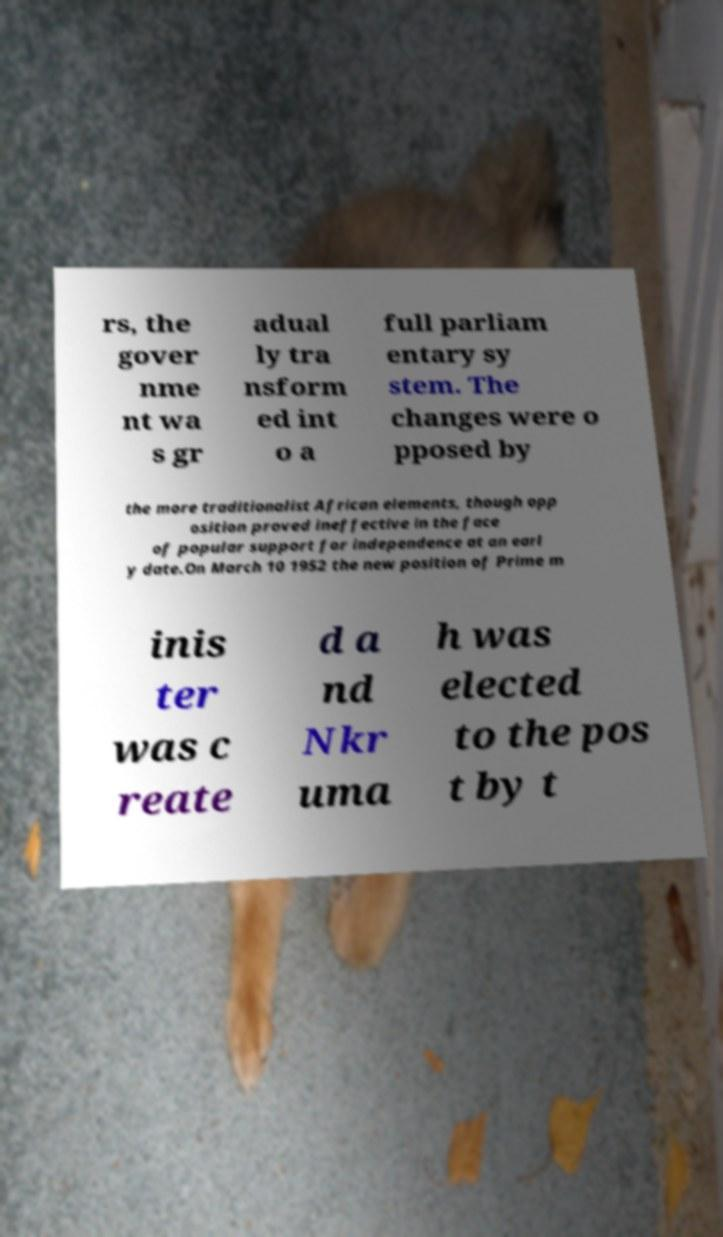I need the written content from this picture converted into text. Can you do that? rs, the gover nme nt wa s gr adual ly tra nsform ed int o a full parliam entary sy stem. The changes were o pposed by the more traditionalist African elements, though opp osition proved ineffective in the face of popular support for independence at an earl y date.On March 10 1952 the new position of Prime m inis ter was c reate d a nd Nkr uma h was elected to the pos t by t 